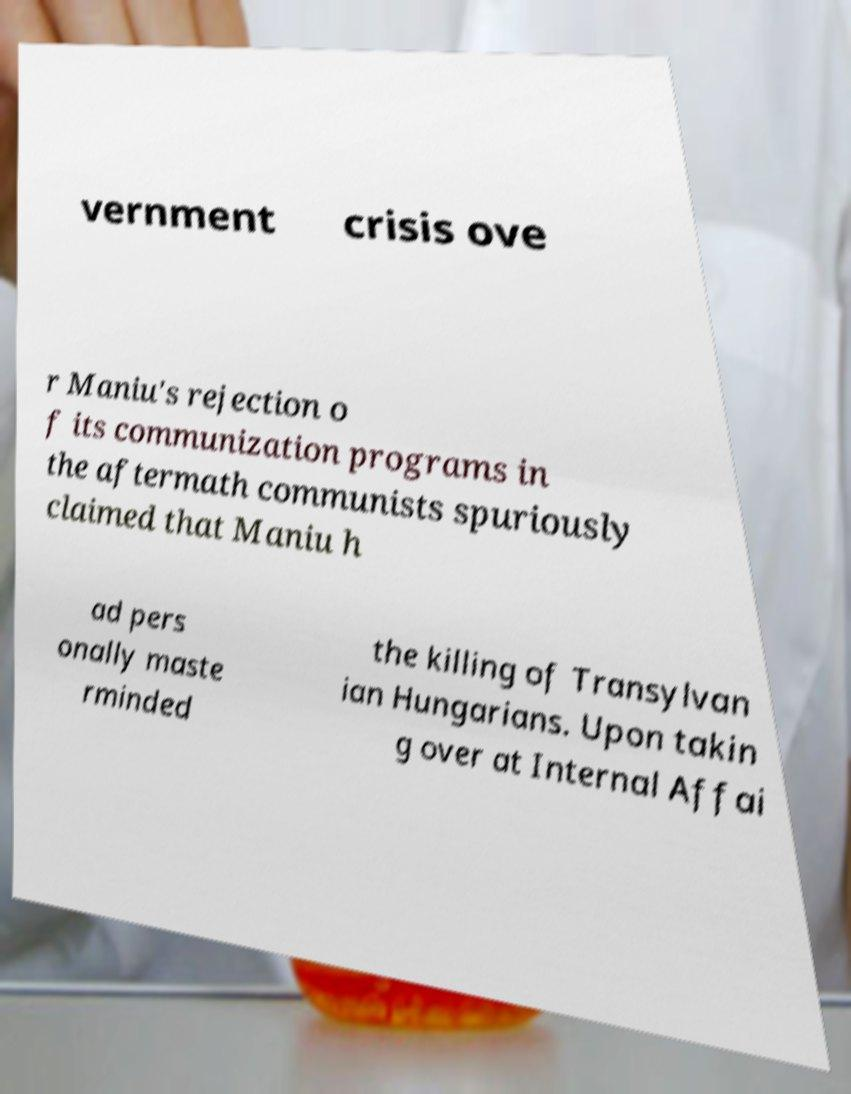Could you extract and type out the text from this image? vernment crisis ove r Maniu's rejection o f its communization programs in the aftermath communists spuriously claimed that Maniu h ad pers onally maste rminded the killing of Transylvan ian Hungarians. Upon takin g over at Internal Affai 